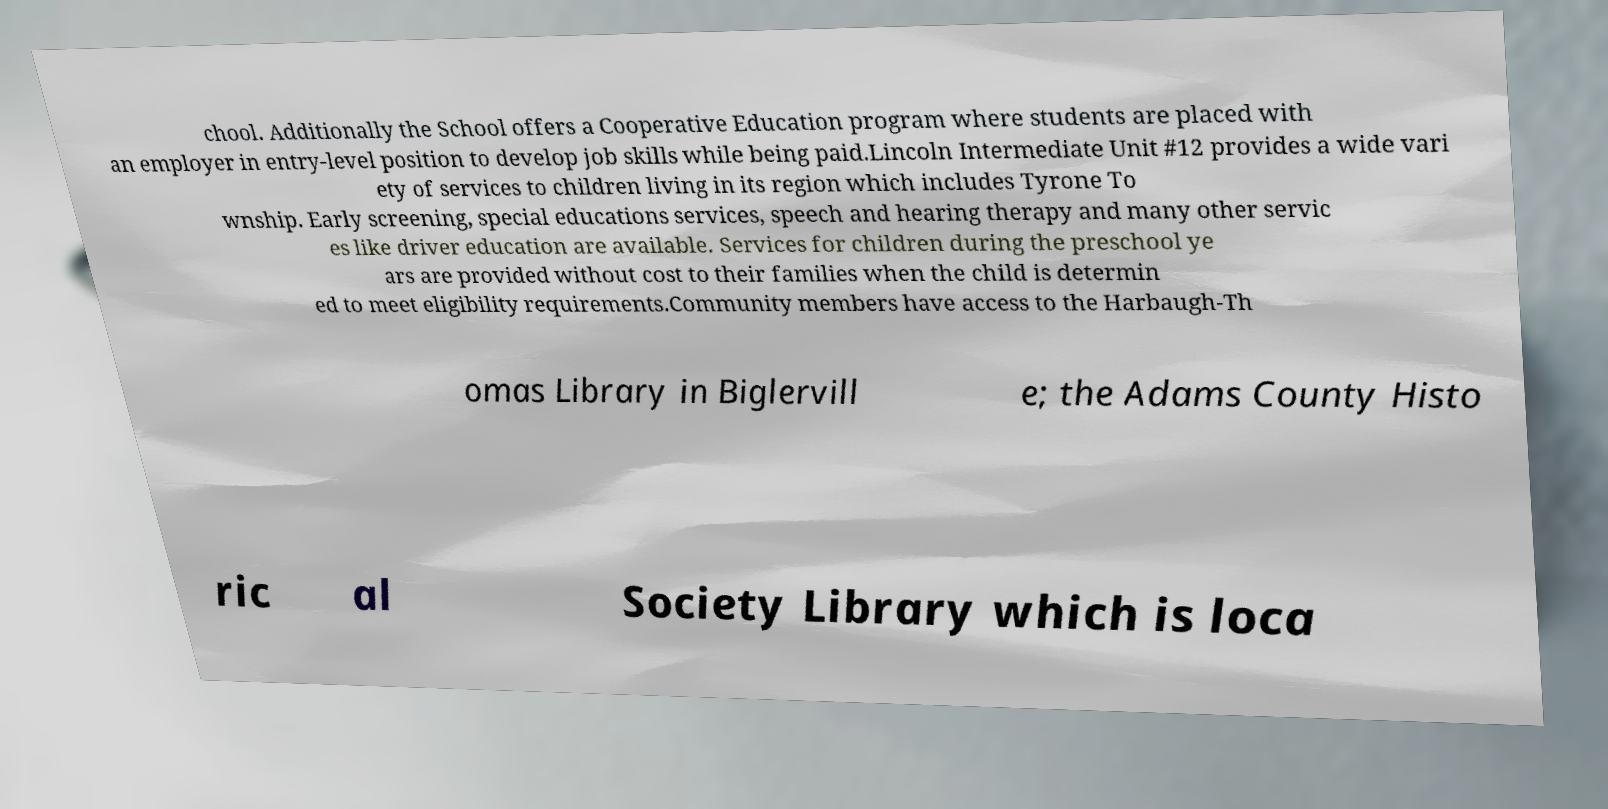Could you assist in decoding the text presented in this image and type it out clearly? chool. Additionally the School offers a Cooperative Education program where students are placed with an employer in entry-level position to develop job skills while being paid.Lincoln Intermediate Unit #12 provides a wide vari ety of services to children living in its region which includes Tyrone To wnship. Early screening, special educations services, speech and hearing therapy and many other servic es like driver education are available. Services for children during the preschool ye ars are provided without cost to their families when the child is determin ed to meet eligibility requirements.Community members have access to the Harbaugh-Th omas Library in Biglervill e; the Adams County Histo ric al Society Library which is loca 